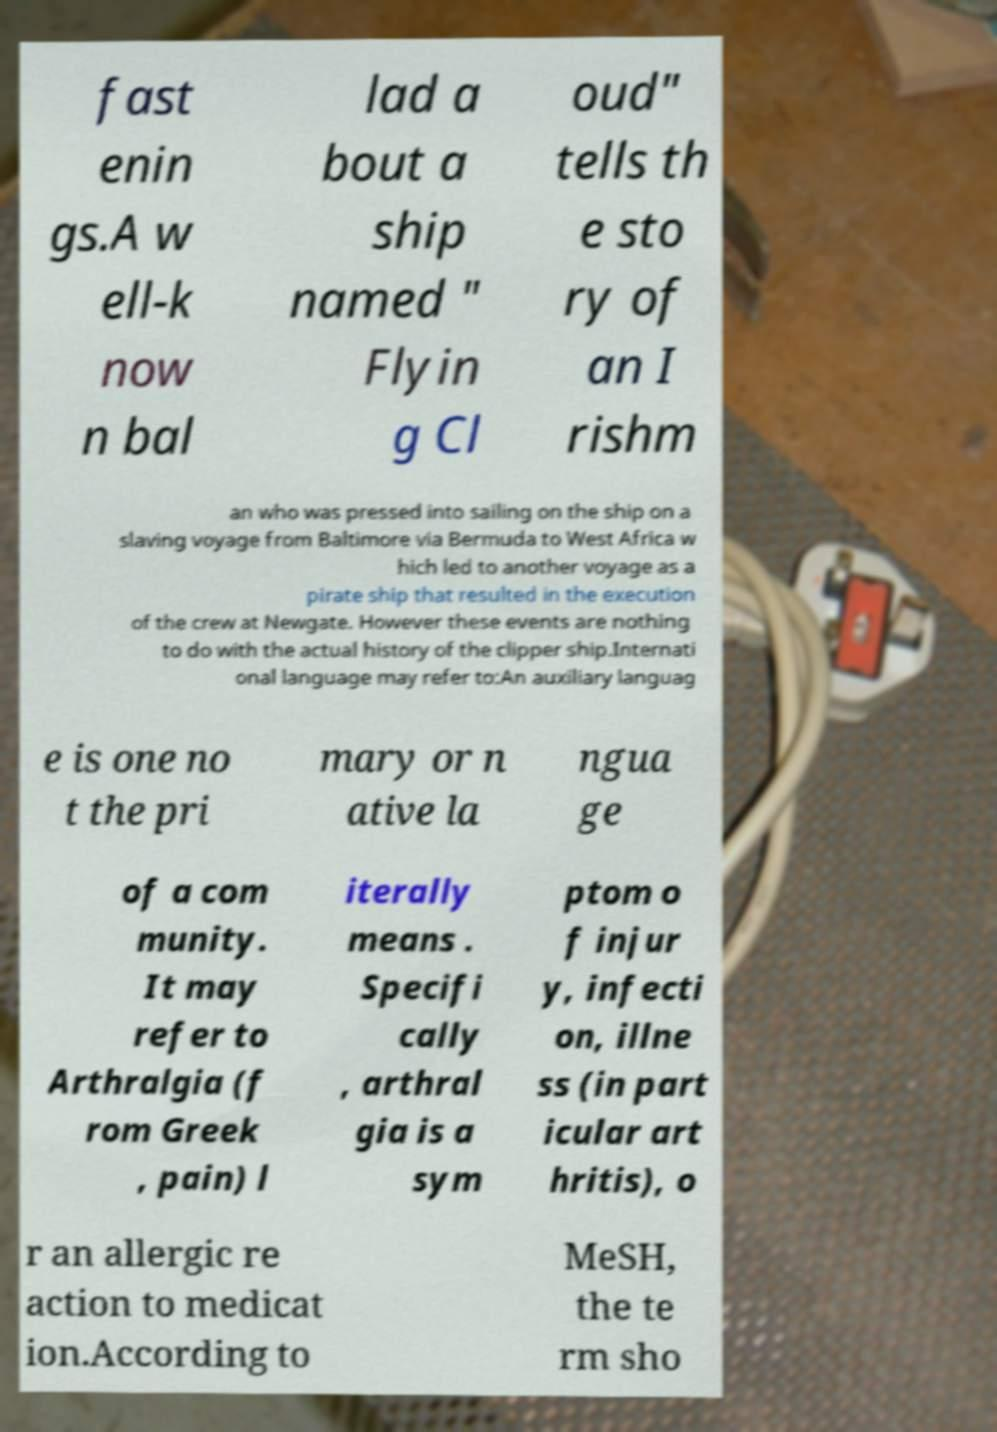What messages or text are displayed in this image? I need them in a readable, typed format. fast enin gs.A w ell-k now n bal lad a bout a ship named " Flyin g Cl oud" tells th e sto ry of an I rishm an who was pressed into sailing on the ship on a slaving voyage from Baltimore via Bermuda to West Africa w hich led to another voyage as a pirate ship that resulted in the execution of the crew at Newgate. However these events are nothing to do with the actual history of the clipper ship.Internati onal language may refer to:An auxiliary languag e is one no t the pri mary or n ative la ngua ge of a com munity. It may refer to Arthralgia (f rom Greek , pain) l iterally means . Specifi cally , arthral gia is a sym ptom o f injur y, infecti on, illne ss (in part icular art hritis), o r an allergic re action to medicat ion.According to MeSH, the te rm sho 